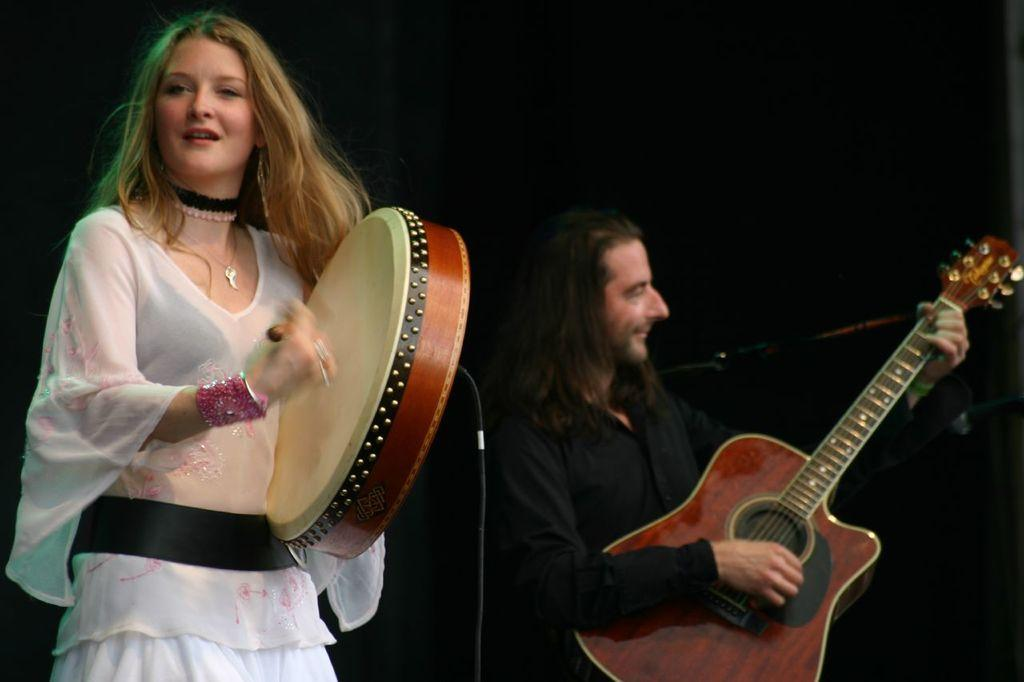What is the woman doing in the image? The woman is playing a musical instrument. What is the man doing in the image? The man is playing a guitar. Can you describe the musical instruments being played in the image? The woman is playing an unspecified musical instrument, and the man is playing a guitar. What type of clam can be seen playing the guitar in the image? There is no clam present in the image, and the guitar is being played by a man, not a clam. 